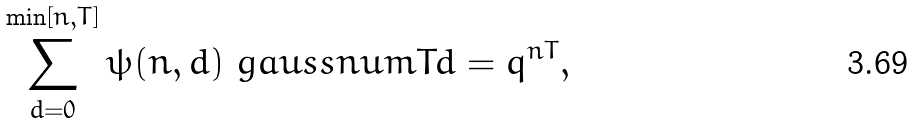Convert formula to latex. <formula><loc_0><loc_0><loc_500><loc_500>\sum _ { d = 0 } ^ { \min [ n , T ] } \psi ( n , d ) \ g a u s s n u m { T } { d } = q ^ { n T } ,</formula> 